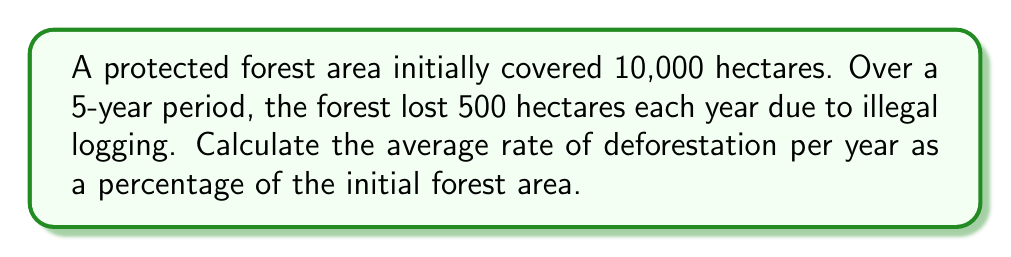Give your solution to this math problem. Let's approach this step-by-step:

1) First, we need to calculate the total area lost over 5 years:
   $$500 \text{ hectares/year} \times 5 \text{ years} = 2500 \text{ hectares}$$

2) Now, we need to express this as a percentage of the initial forest area:
   $$\text{Percentage lost} = \frac{\text{Area lost}}{\text{Initial area}} \times 100\%$$
   $$= \frac{2500}{10000} \times 100\% = 25\%$$

3) This 25% loss occurred over 5 years. To find the average rate per year, we divide by 5:
   $$\text{Average annual rate} = \frac{25\%}{5 \text{ years}} = 5\% \text{ per year}$$

Therefore, the average rate of deforestation is 5% of the initial forest area per year.
Answer: 5% per year 